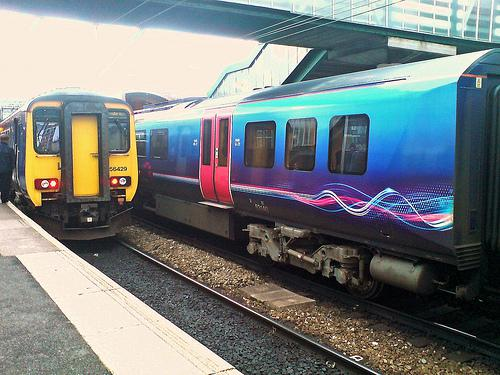Question: what form of transportation is this?
Choices:
A. Planes.
B. Cars.
C. Boats.
D. Trains.
Answer with the letter. Answer: D Question: where are the trains sitting?
Choices:
A. At the station.
B. Near the city.
C. In the tunnel.
D. On the tracks.
Answer with the letter. Answer: D 